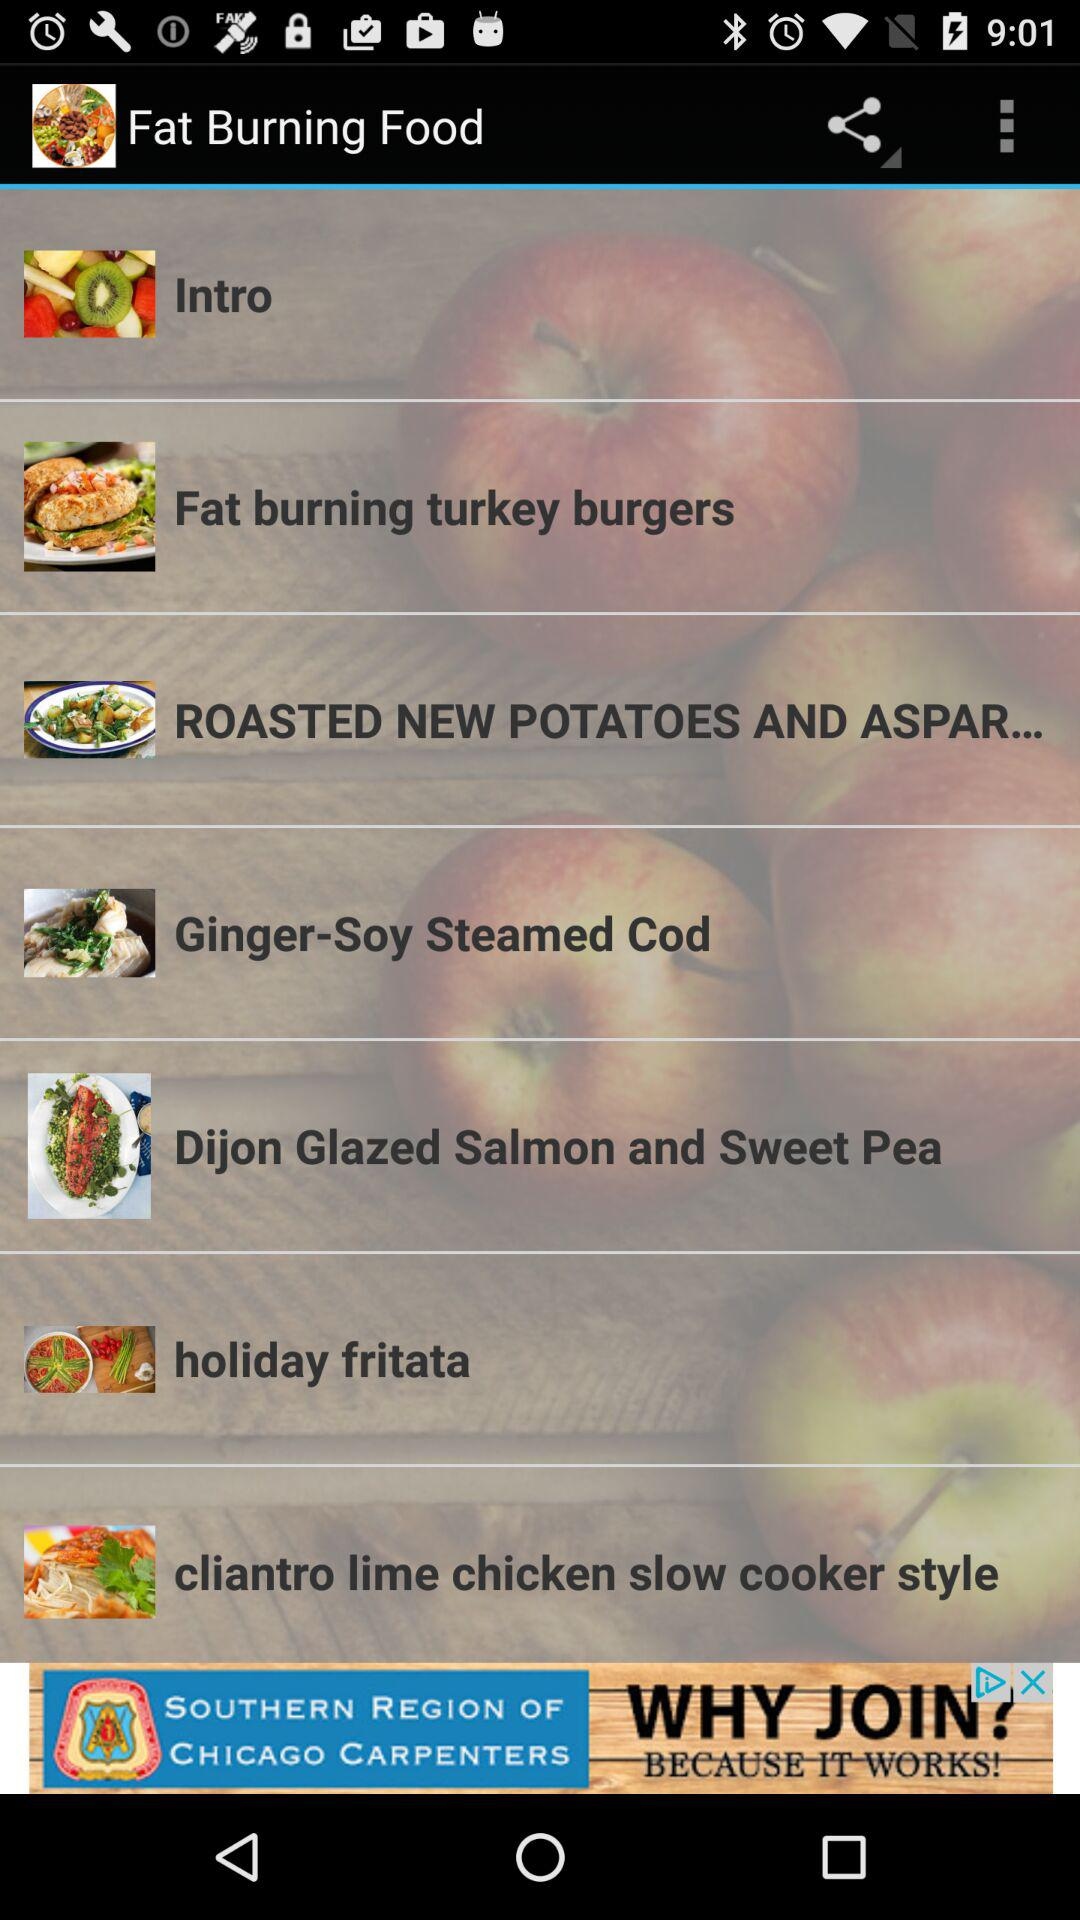What is the application name? The application name is "Fat Burning Food". 